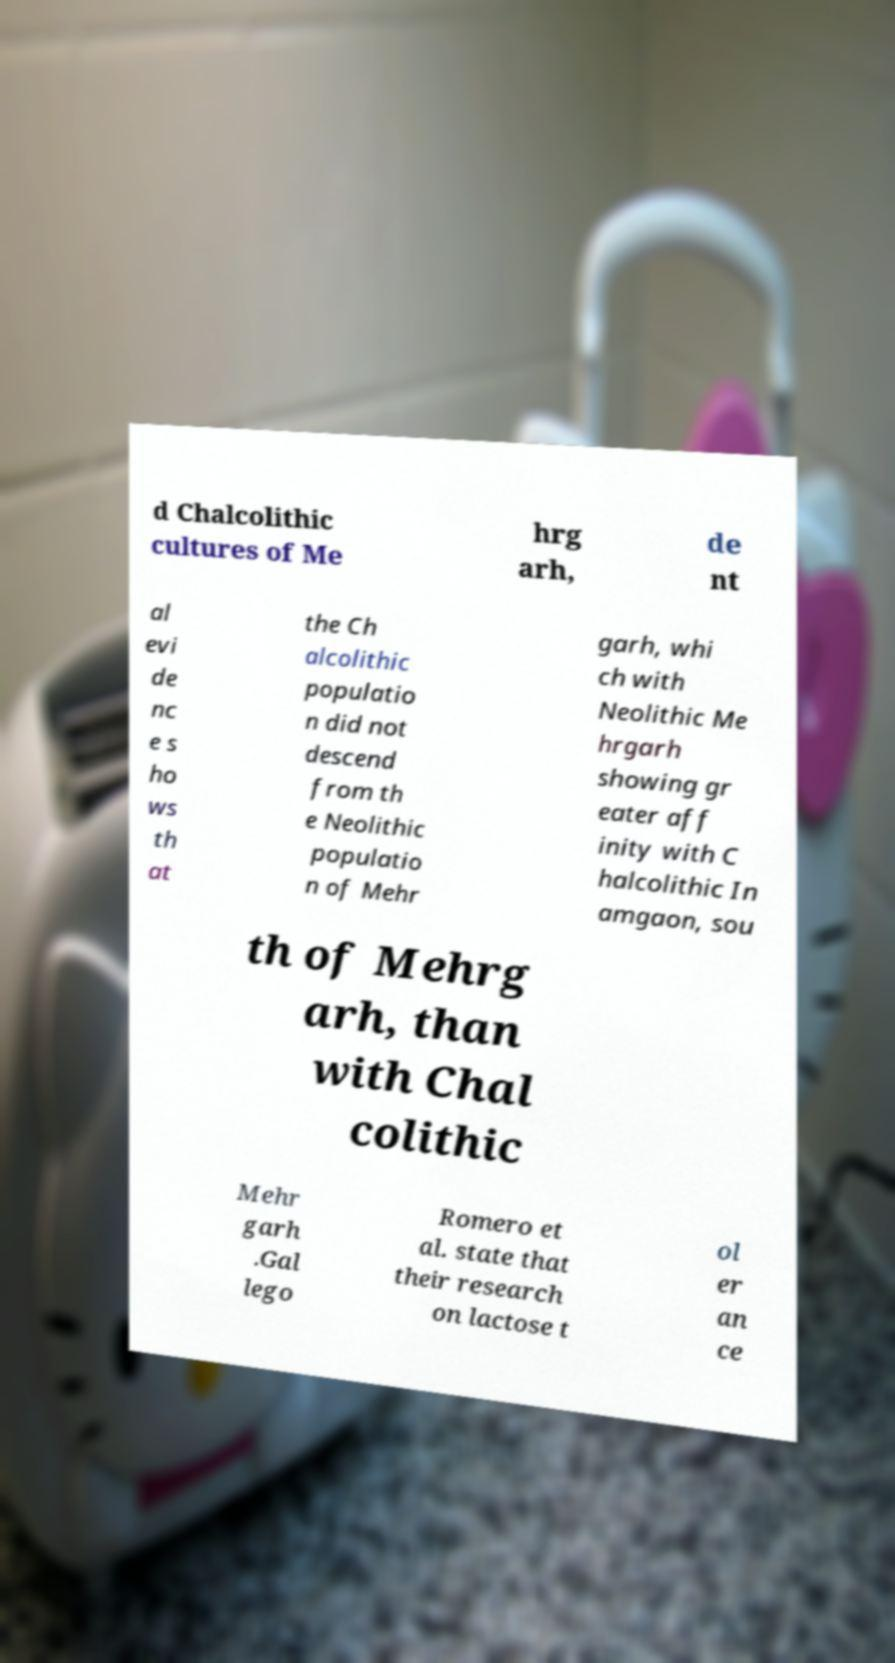What messages or text are displayed in this image? I need them in a readable, typed format. d Chalcolithic cultures of Me hrg arh, de nt al evi de nc e s ho ws th at the Ch alcolithic populatio n did not descend from th e Neolithic populatio n of Mehr garh, whi ch with Neolithic Me hrgarh showing gr eater aff inity with C halcolithic In amgaon, sou th of Mehrg arh, than with Chal colithic Mehr garh .Gal lego Romero et al. state that their research on lactose t ol er an ce 